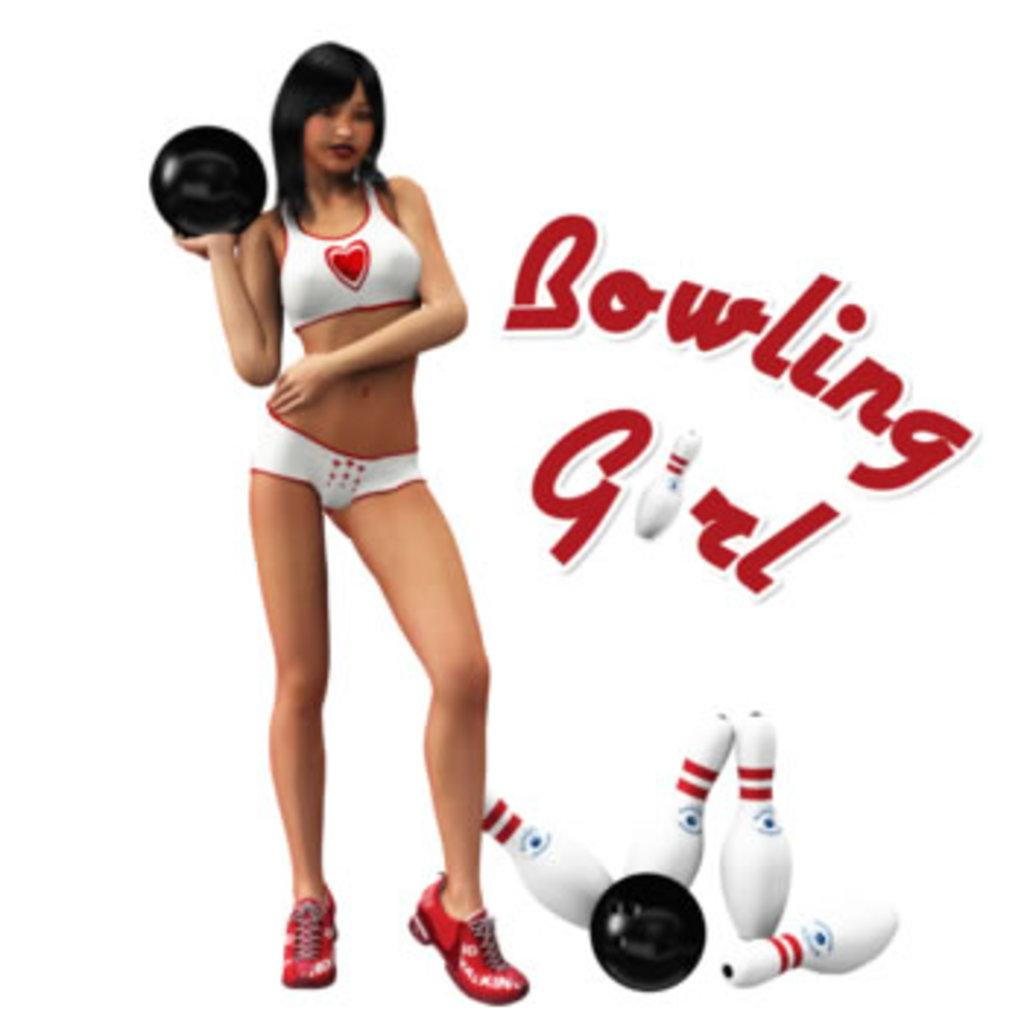<image>
Relay a brief, clear account of the picture shown. A woman in bowling shoes with the caption Bowling Girl. 